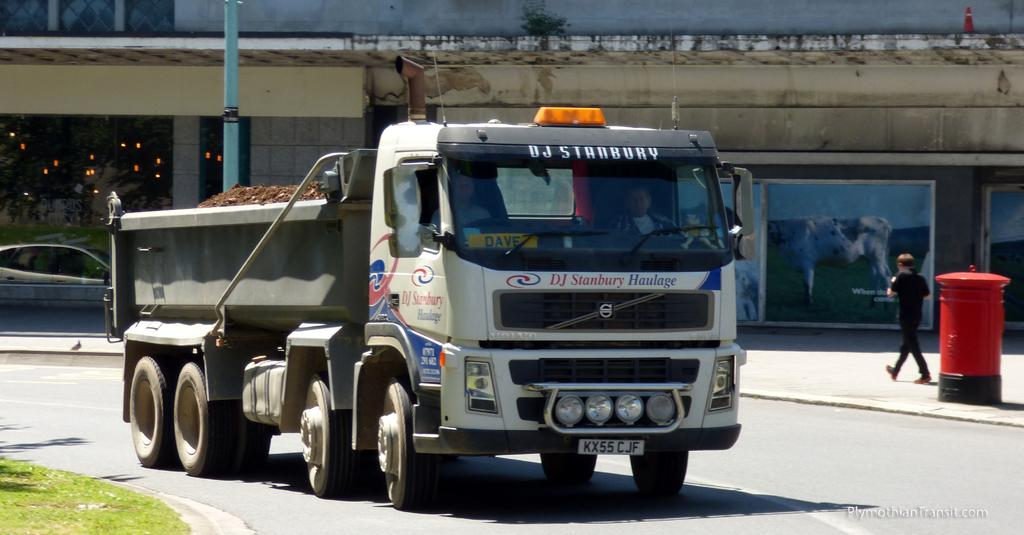What is the main subject of the image? The main subject of the image is a truck. What is the truck doing in the image? The truck is moving on the road in the image. What can be seen in the background of the image? There are buildings in the background of the image. Can you describe any other objects or structures in the image? Yes, there is a letterbox, a pole, and grassland visible in the image. Are there any people in the image? Yes, a person is walking in the image. What type of laborer is working on the border in the image? There is no laborer or border present in the image. What color is the sky in the image? The provided facts do not mention the color of the sky, so it cannot be determined from the image. 